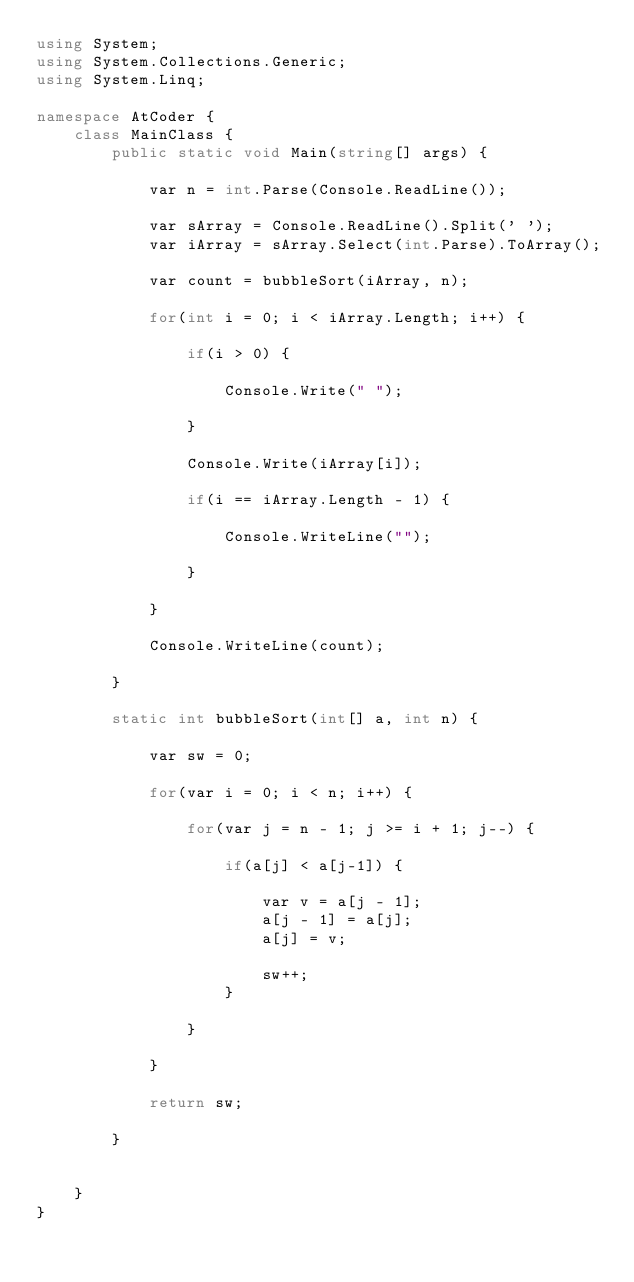<code> <loc_0><loc_0><loc_500><loc_500><_C#_>using System;
using System.Collections.Generic;
using System.Linq;

namespace AtCoder {
    class MainClass {
        public static void Main(string[] args) {

            var n = int.Parse(Console.ReadLine());

            var sArray = Console.ReadLine().Split(' ');
            var iArray = sArray.Select(int.Parse).ToArray();

            var count = bubbleSort(iArray, n);

            for(int i = 0; i < iArray.Length; i++) {

                if(i > 0) {

                    Console.Write(" ");

                }

                Console.Write(iArray[i]);

                if(i == iArray.Length - 1) {

                    Console.WriteLine("");

                }

            }

            Console.WriteLine(count);

        }

        static int bubbleSort(int[] a, int n) {

            var sw = 0;

            for(var i = 0; i < n; i++) {

                for(var j = n - 1; j >= i + 1; j--) {

                    if(a[j] < a[j-1]) {

                        var v = a[j - 1];
                        a[j - 1] = a[j];
                        a[j] = v;

                        sw++;
                    }

                }

            }

            return sw;

        }

        
    }
}

</code> 